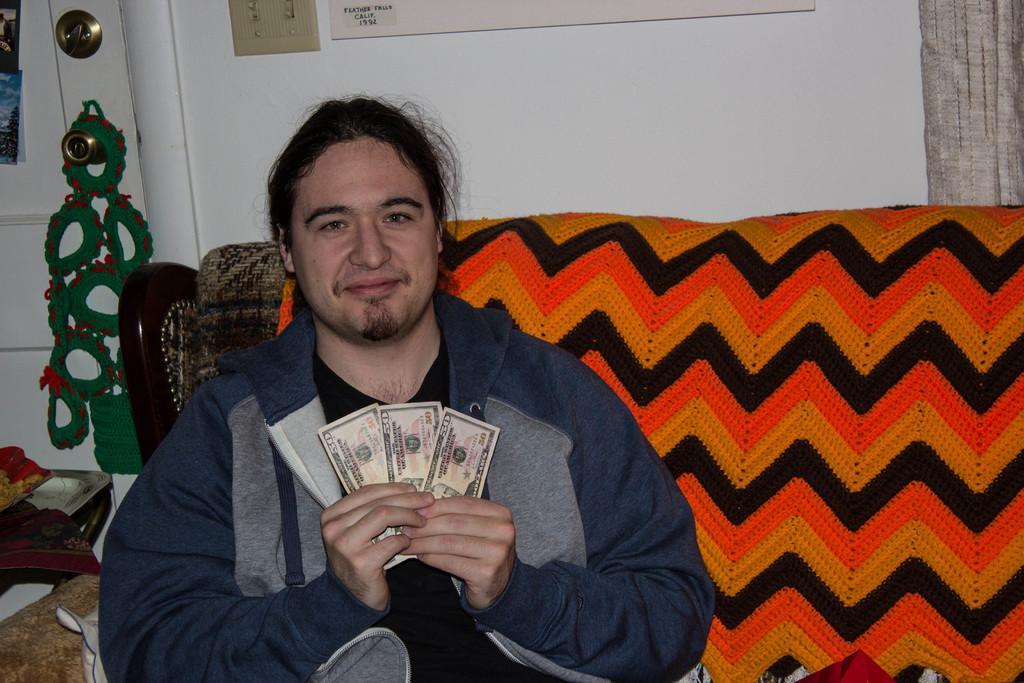In one or two sentences, can you explain what this image depicts? In this image there is a man on a sofa, holding money in his hand, in the background there is a wall. 